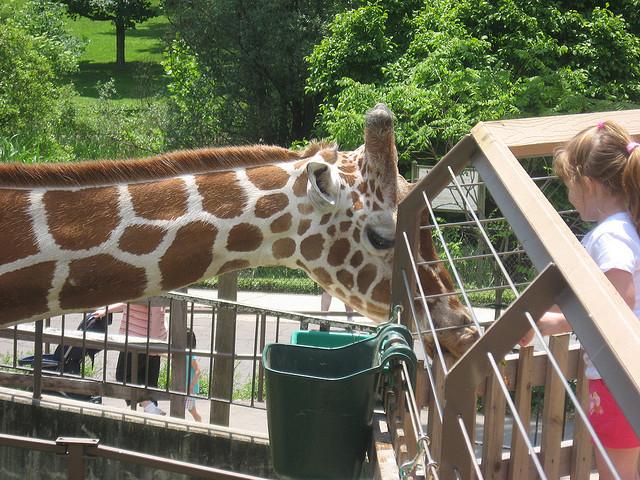What animal is this?
Be succinct. Giraffe. What is the person in the background pushing?
Concise answer only. Stroller. How many children?
Write a very short answer. 2. 